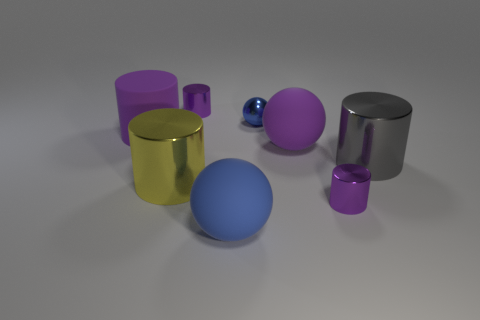Subtract all green blocks. How many purple cylinders are left? 3 Subtract 2 cylinders. How many cylinders are left? 3 Subtract all yellow cylinders. How many cylinders are left? 4 Subtract all gray metal cylinders. How many cylinders are left? 4 Subtract all yellow cylinders. Subtract all purple cubes. How many cylinders are left? 4 Add 1 metallic cylinders. How many objects exist? 9 Subtract all cylinders. How many objects are left? 3 Add 4 large gray metallic things. How many large gray metallic things exist? 5 Subtract 0 brown spheres. How many objects are left? 8 Subtract all matte cylinders. Subtract all large brown objects. How many objects are left? 7 